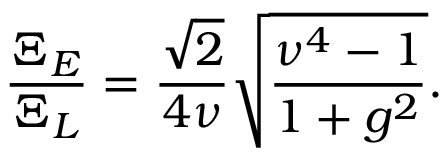<formula> <loc_0><loc_0><loc_500><loc_500>\frac { \Xi _ { E } } { \Xi _ { L } } = \frac { \sqrt { 2 } } { 4 \nu } \sqrt { \frac { \nu ^ { 4 } - 1 } { 1 + g ^ { 2 } } } .</formula> 